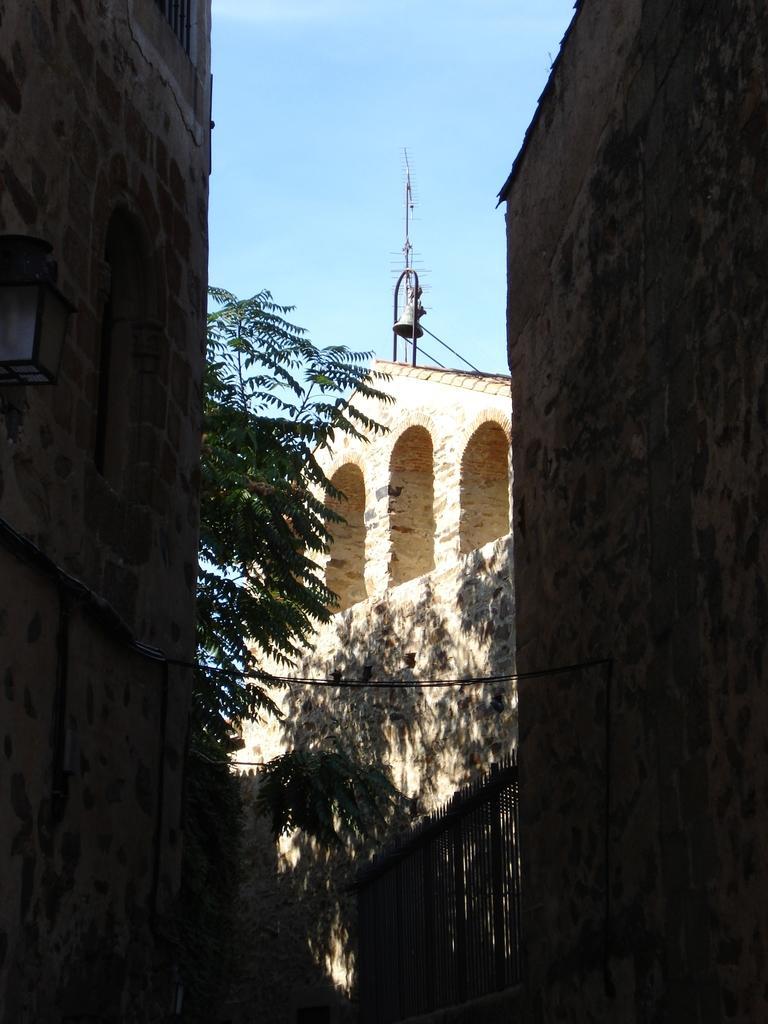In one or two sentences, can you explain what this image depicts? In this picture we can see buildings, bell, pole, tree, lamp, grills, wall are there. At the top of the image clouds are present in the sky. 